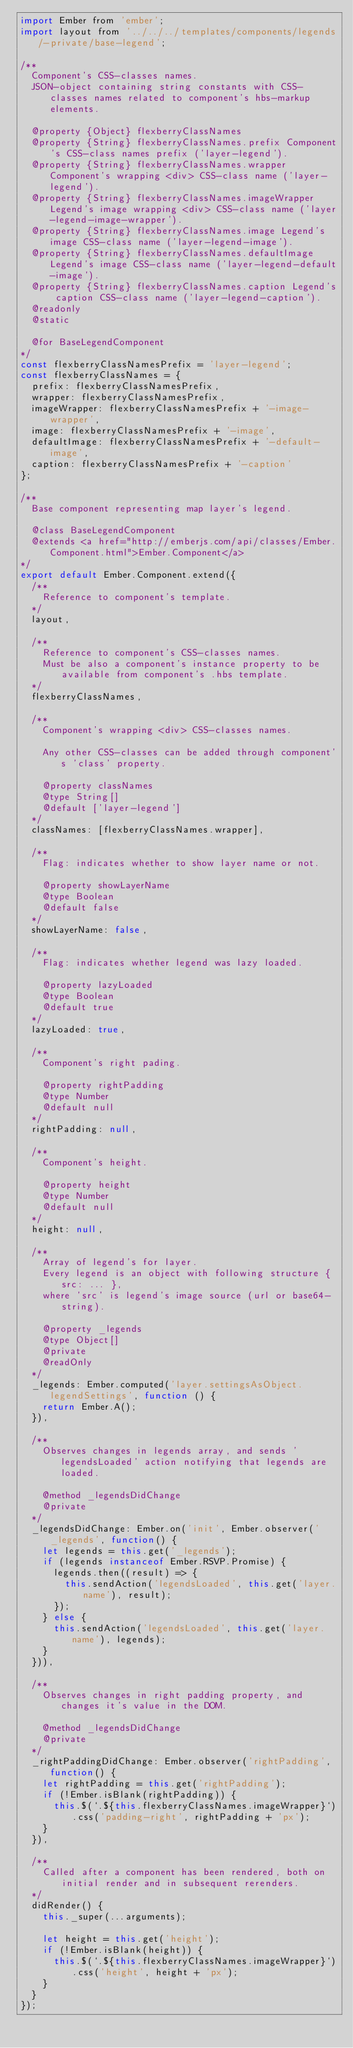Convert code to text. <code><loc_0><loc_0><loc_500><loc_500><_JavaScript_>import Ember from 'ember';
import layout from '../../../templates/components/legends/-private/base-legend';

/**
  Component's CSS-classes names.
  JSON-object containing string constants with CSS-classes names related to component's hbs-markup elements.

  @property {Object} flexberryClassNames
  @property {String} flexberryClassNames.prefix Component's CSS-class names prefix ('layer-legend').
  @property {String} flexberryClassNames.wrapper Component's wrapping <div> CSS-class name ('layer-legend').
  @property {String} flexberryClassNames.imageWrapper Legend's image wrapping <div> CSS-class name ('layer-legend-image-wrapper').
  @property {String} flexberryClassNames.image Legend's image CSS-class name ('layer-legend-image').
  @property {String} flexberryClassNames.defaultImage Legend's image CSS-class name ('layer-legend-default-image').
  @property {String} flexberryClassNames.caption Legend's caption CSS-class name ('layer-legend-caption').
  @readonly
  @static

  @for BaseLegendComponent
*/
const flexberryClassNamesPrefix = 'layer-legend';
const flexberryClassNames = {
  prefix: flexberryClassNamesPrefix,
  wrapper: flexberryClassNamesPrefix,
  imageWrapper: flexberryClassNamesPrefix + '-image-wrapper',
  image: flexberryClassNamesPrefix + '-image',
  defaultImage: flexberryClassNamesPrefix + '-default-image',
  caption: flexberryClassNamesPrefix + '-caption'
};

/**
  Base component representing map layer's legend.

  @class BaseLegendComponent
  @extends <a href="http://emberjs.com/api/classes/Ember.Component.html">Ember.Component</a>
*/
export default Ember.Component.extend({
  /**
    Reference to component's template.
  */
  layout,

  /**
    Reference to component's CSS-classes names.
    Must be also a component's instance property to be available from component's .hbs template.
  */
  flexberryClassNames,

  /**
    Component's wrapping <div> CSS-classes names.

    Any other CSS-classes can be added through component's 'class' property.

    @property classNames
    @type String[]
    @default ['layer-legend']
  */
  classNames: [flexberryClassNames.wrapper],

  /**
    Flag: indicates whether to show layer name or not.

    @property showLayerName
    @type Boolean
    @default false
  */
  showLayerName: false,

  /**
    Flag: indicates whether legend was lazy loaded.

    @property lazyLoaded
    @type Boolean
    @default true
  */
  lazyLoaded: true,

  /**
    Component's right pading.

    @property rightPadding
    @type Number
    @default null
  */
  rightPadding: null,

  /**
    Component's height.

    @property height
    @type Number
    @default null
  */
  height: null,

  /**
    Array of legend's for layer.
    Every legend is an object with following structure { src: ... },
    where 'src' is legend's image source (url or base64-string).

    @property _legends
    @type Object[]
    @private
    @readOnly
  */
  _legends: Ember.computed('layer.settingsAsObject.legendSettings', function () {
    return Ember.A();
  }),

  /**
    Observes changes in legends array, and sends 'legendsLoaded' action notifying that legends are loaded.

    @method _legendsDidChange
    @private
  */
  _legendsDidChange: Ember.on('init', Ember.observer('_legends', function() {
    let legends = this.get('_legends');
    if (legends instanceof Ember.RSVP.Promise) {
      legends.then((result) => {
        this.sendAction('legendsLoaded', this.get('layer.name'), result);
      });
    } else {
      this.sendAction('legendsLoaded', this.get('layer.name'), legends);
    }
  })),

  /**
    Observes changes in right padding property, and changes it's value in the DOM.

    @method _legendsDidChange
    @private
  */
  _rightPaddingDidChange: Ember.observer('rightPadding', function() {
    let rightPadding = this.get('rightPadding');
    if (!Ember.isBlank(rightPadding)) {
      this.$(`.${this.flexberryClassNames.imageWrapper}`).css('padding-right', rightPadding + 'px');
    }
  }),

  /**
    Called after a component has been rendered, both on initial render and in subsequent rerenders.
  */
  didRender() {
    this._super(...arguments);

    let height = this.get('height');
    if (!Ember.isBlank(height)) {
      this.$(`.${this.flexberryClassNames.imageWrapper}`).css('height', height + 'px');
    }
  }
});
</code> 